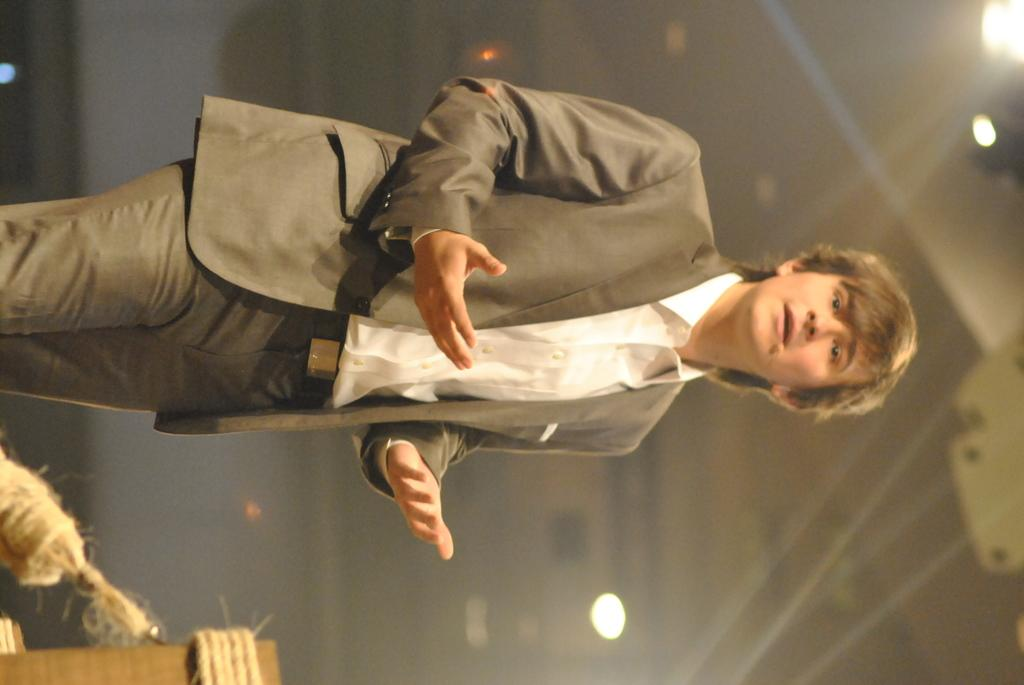What is the main subject of the image? There is a man standing in the image. What is the man doing in the image? The man is talking. Can you describe any objects in the image? Yes, there are objects in the image. How would you describe the background of the image? The background of the image is blurry. What can be seen in the background of the image? There are lights visible in the background of the image. How many books can be seen on the table in the image? There are no books visible in the image. --- Facts: 1. There is a person in the image. 2. The person is wearing a hat. 3. The person is holding a balloon. 4. The background of the image is a park. 5. There are trees in the background of the image. Absurd Topics: bicycle, parrot Conversation: What is the main subject of the image? There is a person in the image. What is the person wearing in the image? The person is wearing a hat. What is the person holding in the image? The person is holding a balloon. Can you describe the background of the image? The background of the image is a park. What can be seen in the background of the image? There are trees in the background of the image. Reasoning: Let's think step by step in order to ${produce the conversation}. We start by identifying the main subject of the image, which is the person. Next, we describe specific features of the person, such as the hat. Then, we observe the actions of the person, noting that they are holding a balloon. Finally, we describe the natural setting visible in the background of the image, which includes trees in a park. Absurd Question/Answer: Can you see a parrot in the image? There is no parrot present in the image. --- Facts: 1. There is a cat in the image. 2. The cat is sitting on a chair. 3. The cat is looking at a toy. 4. The background of the image is a living room. 5. There is a fireplace in the background of the image. Absurd Topics: elephant, piano Conversation: What type of animal is in the image? There is a cat in the image. What is the cat doing in the image? The cat is sitting on a chair. What is the cat looking at in the image? The cat is looking at a toy. Can you describe the background of the image? The background of the image is a living room. What can be seen in the background of the image? There is a fireplace in the background of the image. Reasoning: Let's think step by step in order to ${ 